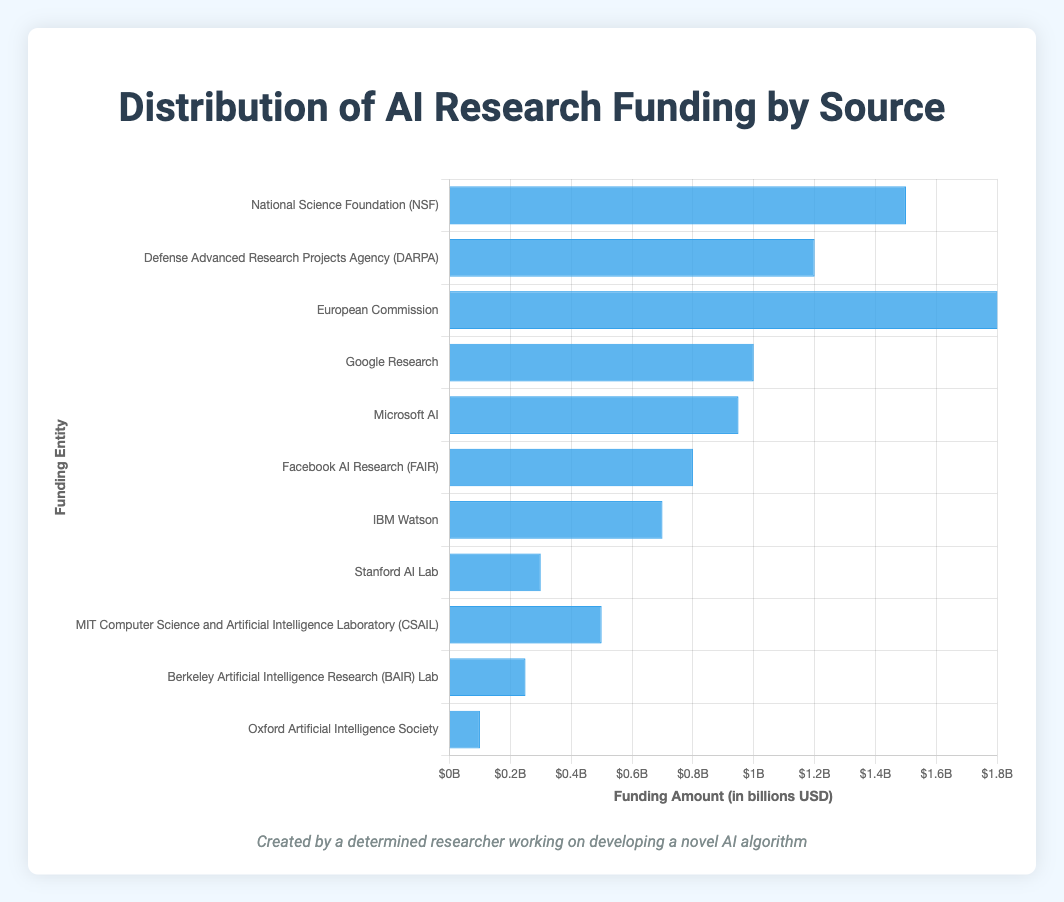Who received the highest funding among the Government sources? From the chart, the European Commission received the highest funding among the Government sources. This is evidenced by the tallest blue bar representing €1.8 billion.
Answer: European Commission Which funding entity has the lowest funding amount, and what is that amount? The Oxford Artificial Intelligence Society received the lowest funding amount, which is €0.1 billion. This can be identified by the shortest blue bar on the chart.
Answer: Oxford Artificial Intelligence Society, €0.1 billion What is the total funding amount provided by the Private Sector? The total funding amount from the Private Sector can be calculated by summing the amounts from Google Research, Microsoft AI, Facebook AI Research (FAIR), and IBM Watson: €1.0B + €0.95B + €0.8B + €0.7B = €3.45 billion.
Answer: €3.45 billion How much more funding did the European Commission provide compared to DARPA? The European Commission provided €1.8 billion while DARPA provided €1.2 billion. The difference is €1.8B - €1.2B = €0.6 billion.
Answer: €0.6 billion Compare the total funding of Academic Grants to that of Private Sector. Which is higher and by how much? The total funding for Academic Grants is €1.15 billion (0.3B + 0.5B + 0.25B + 0.1B), and for the Private Sector it is €3.45 billion. The Private Sector's funding is higher by €3.45B - €1.15B = €2.3 billion.
Answer: Private Sector, €2.3 billion Which source of funding (Government, Private Sector, Academic Grants) has contributed the most to AI research funding? To determine this, sum the funding amounts for each source: Government: €4.5B, Private Sector: €3.45B, Academic Grants: €1.15B. Government has the highest total contribution.
Answer: Government What is the average funding amount provided by the Government entities? Average funding amount from the Government sources is calculated by summing all the amounts and dividing by the number of entities: (€1.5B + €1.2B + €1.8B) / 3 = €4.5B / 3 = €1.5 billion.
Answer: €1.5 billion How much more funding does Google Research receive compared to IBM Watson? Google Research receives €1.0 billion while IBM Watson receives €0.7 billion. The difference is €1.0B - €0.7B = €0.3 billion.
Answer: €0.3 billion Is there any funding entity that received exactly €0.8 billion? Yes, Facebook AI Research (FAIR) received exactly €0.8 billion, represented by one of the blue bars.
Answer: Yes, Facebook AI Research (FAIR) 